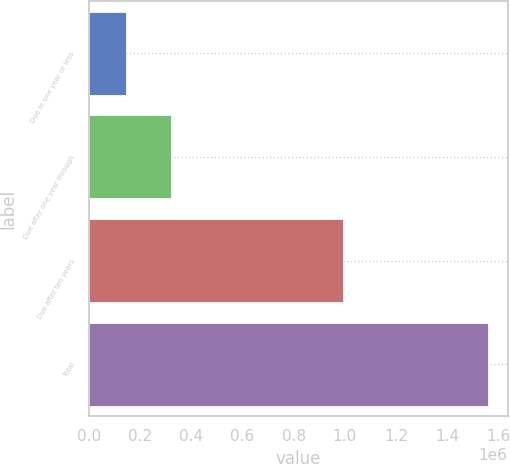<chart> <loc_0><loc_0><loc_500><loc_500><bar_chart><fcel>Due in one year or less<fcel>Due after one year through<fcel>Due after ten years<fcel>Total<nl><fcel>144787<fcel>320067<fcel>992173<fcel>1.55833e+06<nl></chart> 